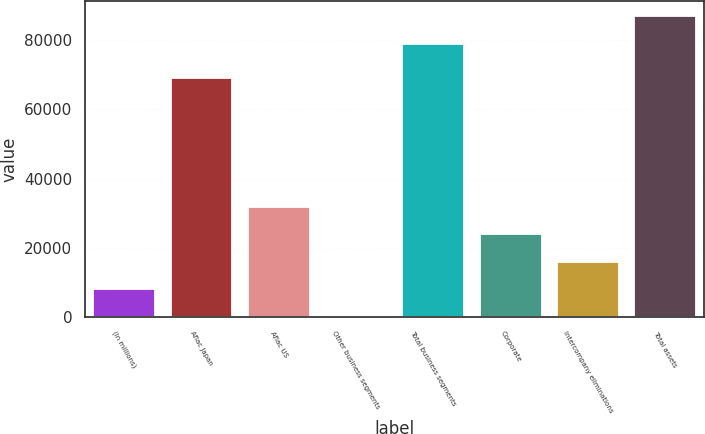<chart> <loc_0><loc_0><loc_500><loc_500><bar_chart><fcel>(In millions)<fcel>Aflac Japan<fcel>Aflac US<fcel>Other business segments<fcel>Total business segments<fcel>Corporate<fcel>Intercompany eliminations<fcel>Total assets<nl><fcel>8082.5<fcel>69141<fcel>31832<fcel>166<fcel>78986<fcel>23915.5<fcel>15999<fcel>86902.5<nl></chart> 